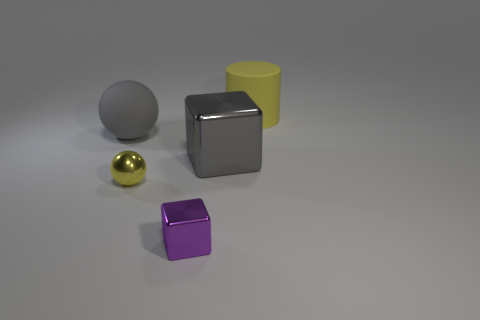Can you describe the shapes of the objects I see? Certainly, there are four distinct objects: a sphere, a cylinder, and two cubes. The sphere is simple and smooth, the cylinder is tall and has a circular cross-section, and the cubes have equal lengths on all edges, with one being silver and reflective and the other purple with a matte finish. 